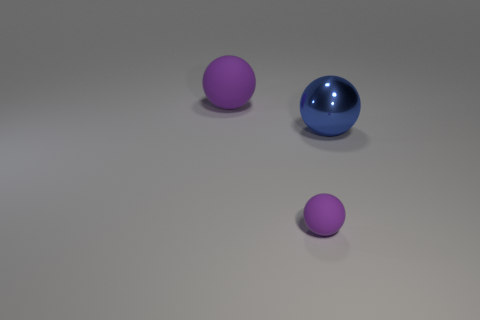What color is the big thing that is the same material as the small ball?
Your response must be concise. Purple. Is the number of tiny spheres greater than the number of small gray metallic cylinders?
Provide a succinct answer. Yes. What is the size of the ball that is on the left side of the big blue metal ball and behind the small sphere?
Make the answer very short. Large. There is a big sphere that is the same color as the small ball; what is its material?
Your answer should be very brief. Rubber. Are there the same number of small objects in front of the big matte object and purple matte spheres?
Keep it short and to the point. No. What color is the ball that is both behind the small purple matte sphere and to the left of the blue metallic ball?
Keep it short and to the point. Purple. There is a large thing on the left side of the purple ball that is to the right of the big rubber object; what is it made of?
Provide a succinct answer. Rubber. The other rubber thing that is the same shape as the small object is what size?
Your answer should be very brief. Large. Does the big sphere that is behind the blue metallic object have the same color as the small ball?
Make the answer very short. Yes. Are there fewer tiny blue blocks than small purple rubber balls?
Provide a short and direct response. Yes. 